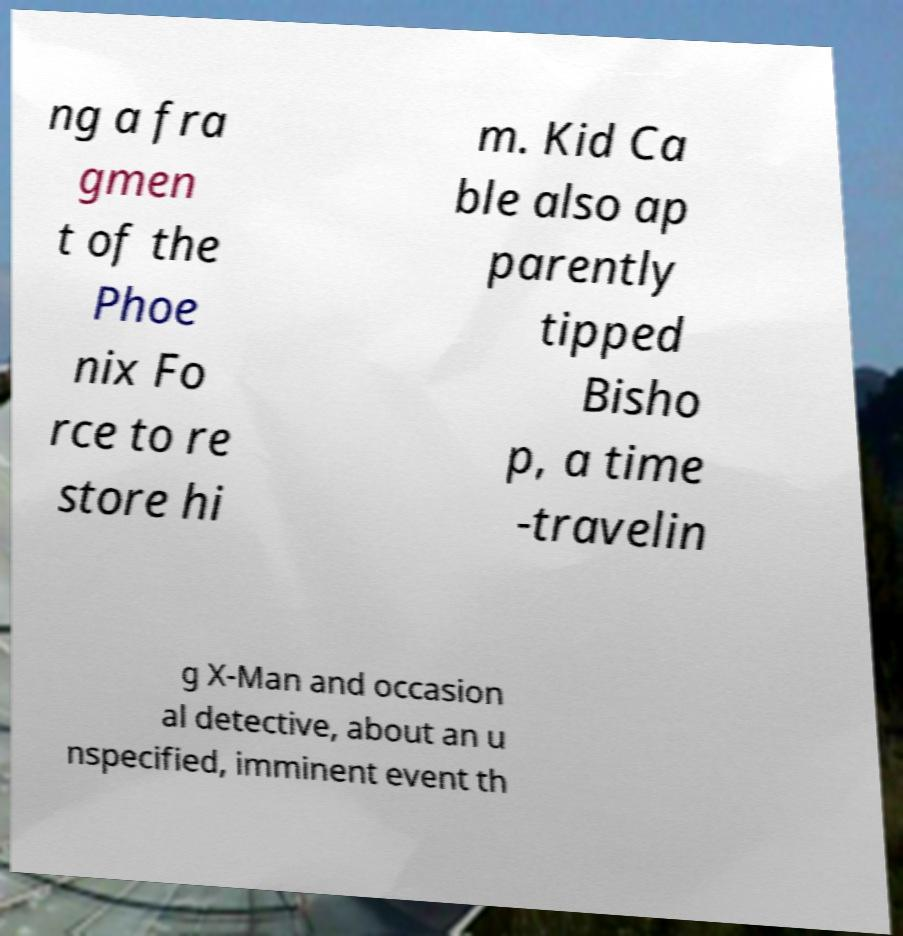Please identify and transcribe the text found in this image. ng a fra gmen t of the Phoe nix Fo rce to re store hi m. Kid Ca ble also ap parently tipped Bisho p, a time -travelin g X-Man and occasion al detective, about an u nspecified, imminent event th 